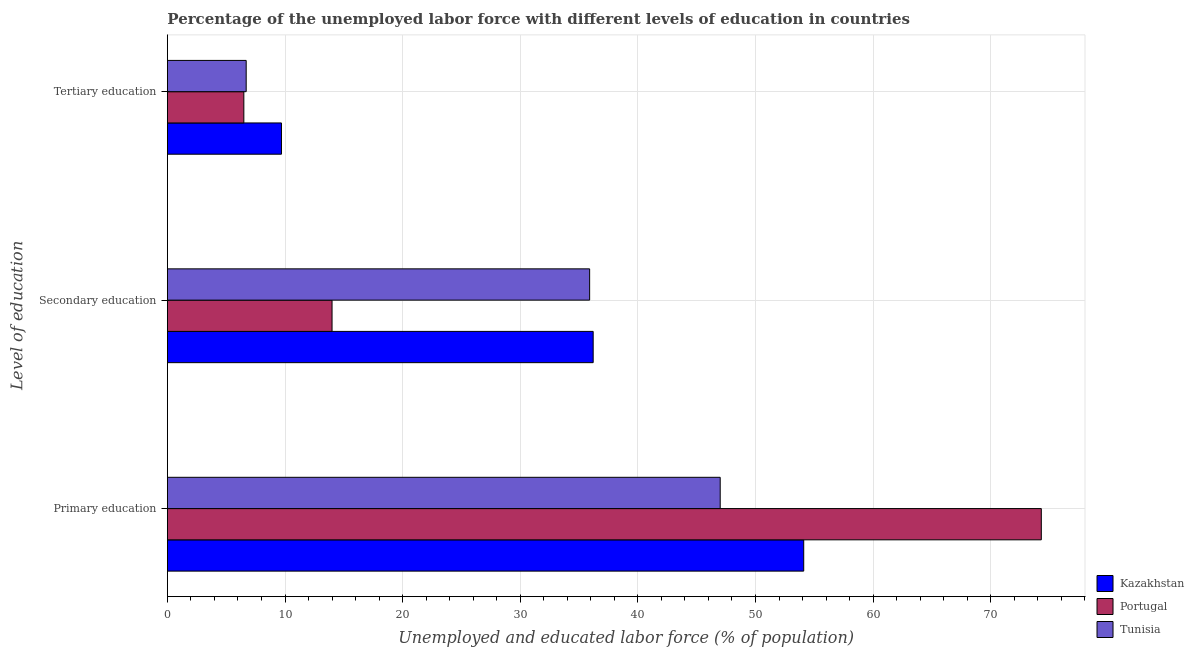How many groups of bars are there?
Provide a short and direct response. 3. Are the number of bars on each tick of the Y-axis equal?
Offer a very short reply. Yes. How many bars are there on the 1st tick from the top?
Offer a terse response. 3. How many bars are there on the 3rd tick from the bottom?
Your answer should be very brief. 3. What is the label of the 1st group of bars from the top?
Offer a terse response. Tertiary education. What is the percentage of labor force who received tertiary education in Tunisia?
Provide a short and direct response. 6.7. Across all countries, what is the maximum percentage of labor force who received primary education?
Make the answer very short. 74.3. In which country was the percentage of labor force who received primary education maximum?
Provide a succinct answer. Portugal. In which country was the percentage of labor force who received primary education minimum?
Your response must be concise. Tunisia. What is the total percentage of labor force who received secondary education in the graph?
Offer a terse response. 86.1. What is the difference between the percentage of labor force who received tertiary education in Kazakhstan and that in Portugal?
Offer a very short reply. 3.2. What is the difference between the percentage of labor force who received secondary education in Kazakhstan and the percentage of labor force who received primary education in Portugal?
Offer a very short reply. -38.1. What is the average percentage of labor force who received tertiary education per country?
Your answer should be compact. 7.63. What is the difference between the percentage of labor force who received secondary education and percentage of labor force who received primary education in Kazakhstan?
Your answer should be very brief. -17.9. What is the ratio of the percentage of labor force who received primary education in Tunisia to that in Portugal?
Keep it short and to the point. 0.63. Is the percentage of labor force who received secondary education in Portugal less than that in Kazakhstan?
Provide a short and direct response. Yes. Is the difference between the percentage of labor force who received primary education in Portugal and Kazakhstan greater than the difference between the percentage of labor force who received tertiary education in Portugal and Kazakhstan?
Give a very brief answer. Yes. What is the difference between the highest and the second highest percentage of labor force who received primary education?
Make the answer very short. 20.2. What is the difference between the highest and the lowest percentage of labor force who received tertiary education?
Provide a short and direct response. 3.2. Is the sum of the percentage of labor force who received secondary education in Tunisia and Portugal greater than the maximum percentage of labor force who received primary education across all countries?
Make the answer very short. No. What does the 1st bar from the top in Primary education represents?
Your response must be concise. Tunisia. Is it the case that in every country, the sum of the percentage of labor force who received primary education and percentage of labor force who received secondary education is greater than the percentage of labor force who received tertiary education?
Give a very brief answer. Yes. Are all the bars in the graph horizontal?
Provide a succinct answer. Yes. What is the difference between two consecutive major ticks on the X-axis?
Keep it short and to the point. 10. Are the values on the major ticks of X-axis written in scientific E-notation?
Make the answer very short. No. Does the graph contain grids?
Your answer should be very brief. Yes. Where does the legend appear in the graph?
Make the answer very short. Bottom right. How many legend labels are there?
Your answer should be very brief. 3. How are the legend labels stacked?
Your answer should be compact. Vertical. What is the title of the graph?
Provide a short and direct response. Percentage of the unemployed labor force with different levels of education in countries. Does "Mongolia" appear as one of the legend labels in the graph?
Your answer should be compact. No. What is the label or title of the X-axis?
Your response must be concise. Unemployed and educated labor force (% of population). What is the label or title of the Y-axis?
Your answer should be compact. Level of education. What is the Unemployed and educated labor force (% of population) in Kazakhstan in Primary education?
Your answer should be very brief. 54.1. What is the Unemployed and educated labor force (% of population) of Portugal in Primary education?
Your answer should be compact. 74.3. What is the Unemployed and educated labor force (% of population) of Tunisia in Primary education?
Offer a terse response. 47. What is the Unemployed and educated labor force (% of population) of Kazakhstan in Secondary education?
Provide a succinct answer. 36.2. What is the Unemployed and educated labor force (% of population) of Portugal in Secondary education?
Your answer should be compact. 14. What is the Unemployed and educated labor force (% of population) of Tunisia in Secondary education?
Offer a terse response. 35.9. What is the Unemployed and educated labor force (% of population) in Kazakhstan in Tertiary education?
Offer a terse response. 9.7. What is the Unemployed and educated labor force (% of population) of Tunisia in Tertiary education?
Your response must be concise. 6.7. Across all Level of education, what is the maximum Unemployed and educated labor force (% of population) in Kazakhstan?
Your response must be concise. 54.1. Across all Level of education, what is the maximum Unemployed and educated labor force (% of population) of Portugal?
Your response must be concise. 74.3. Across all Level of education, what is the maximum Unemployed and educated labor force (% of population) of Tunisia?
Provide a succinct answer. 47. Across all Level of education, what is the minimum Unemployed and educated labor force (% of population) of Kazakhstan?
Ensure brevity in your answer.  9.7. Across all Level of education, what is the minimum Unemployed and educated labor force (% of population) in Portugal?
Provide a succinct answer. 6.5. Across all Level of education, what is the minimum Unemployed and educated labor force (% of population) of Tunisia?
Offer a terse response. 6.7. What is the total Unemployed and educated labor force (% of population) in Kazakhstan in the graph?
Ensure brevity in your answer.  100. What is the total Unemployed and educated labor force (% of population) of Portugal in the graph?
Your answer should be very brief. 94.8. What is the total Unemployed and educated labor force (% of population) of Tunisia in the graph?
Offer a terse response. 89.6. What is the difference between the Unemployed and educated labor force (% of population) in Portugal in Primary education and that in Secondary education?
Ensure brevity in your answer.  60.3. What is the difference between the Unemployed and educated labor force (% of population) in Tunisia in Primary education and that in Secondary education?
Provide a succinct answer. 11.1. What is the difference between the Unemployed and educated labor force (% of population) in Kazakhstan in Primary education and that in Tertiary education?
Your response must be concise. 44.4. What is the difference between the Unemployed and educated labor force (% of population) of Portugal in Primary education and that in Tertiary education?
Offer a terse response. 67.8. What is the difference between the Unemployed and educated labor force (% of population) in Tunisia in Primary education and that in Tertiary education?
Give a very brief answer. 40.3. What is the difference between the Unemployed and educated labor force (% of population) of Kazakhstan in Secondary education and that in Tertiary education?
Offer a terse response. 26.5. What is the difference between the Unemployed and educated labor force (% of population) in Tunisia in Secondary education and that in Tertiary education?
Your answer should be very brief. 29.2. What is the difference between the Unemployed and educated labor force (% of population) in Kazakhstan in Primary education and the Unemployed and educated labor force (% of population) in Portugal in Secondary education?
Your answer should be compact. 40.1. What is the difference between the Unemployed and educated labor force (% of population) in Kazakhstan in Primary education and the Unemployed and educated labor force (% of population) in Tunisia in Secondary education?
Offer a terse response. 18.2. What is the difference between the Unemployed and educated labor force (% of population) in Portugal in Primary education and the Unemployed and educated labor force (% of population) in Tunisia in Secondary education?
Your answer should be very brief. 38.4. What is the difference between the Unemployed and educated labor force (% of population) of Kazakhstan in Primary education and the Unemployed and educated labor force (% of population) of Portugal in Tertiary education?
Your answer should be very brief. 47.6. What is the difference between the Unemployed and educated labor force (% of population) in Kazakhstan in Primary education and the Unemployed and educated labor force (% of population) in Tunisia in Tertiary education?
Ensure brevity in your answer.  47.4. What is the difference between the Unemployed and educated labor force (% of population) in Portugal in Primary education and the Unemployed and educated labor force (% of population) in Tunisia in Tertiary education?
Provide a succinct answer. 67.6. What is the difference between the Unemployed and educated labor force (% of population) in Kazakhstan in Secondary education and the Unemployed and educated labor force (% of population) in Portugal in Tertiary education?
Ensure brevity in your answer.  29.7. What is the difference between the Unemployed and educated labor force (% of population) of Kazakhstan in Secondary education and the Unemployed and educated labor force (% of population) of Tunisia in Tertiary education?
Offer a terse response. 29.5. What is the average Unemployed and educated labor force (% of population) in Kazakhstan per Level of education?
Your response must be concise. 33.33. What is the average Unemployed and educated labor force (% of population) of Portugal per Level of education?
Your answer should be compact. 31.6. What is the average Unemployed and educated labor force (% of population) in Tunisia per Level of education?
Keep it short and to the point. 29.87. What is the difference between the Unemployed and educated labor force (% of population) in Kazakhstan and Unemployed and educated labor force (% of population) in Portugal in Primary education?
Your answer should be compact. -20.2. What is the difference between the Unemployed and educated labor force (% of population) of Portugal and Unemployed and educated labor force (% of population) of Tunisia in Primary education?
Make the answer very short. 27.3. What is the difference between the Unemployed and educated labor force (% of population) of Kazakhstan and Unemployed and educated labor force (% of population) of Portugal in Secondary education?
Keep it short and to the point. 22.2. What is the difference between the Unemployed and educated labor force (% of population) in Portugal and Unemployed and educated labor force (% of population) in Tunisia in Secondary education?
Your response must be concise. -21.9. What is the difference between the Unemployed and educated labor force (% of population) in Kazakhstan and Unemployed and educated labor force (% of population) in Portugal in Tertiary education?
Provide a succinct answer. 3.2. What is the ratio of the Unemployed and educated labor force (% of population) of Kazakhstan in Primary education to that in Secondary education?
Keep it short and to the point. 1.49. What is the ratio of the Unemployed and educated labor force (% of population) of Portugal in Primary education to that in Secondary education?
Make the answer very short. 5.31. What is the ratio of the Unemployed and educated labor force (% of population) of Tunisia in Primary education to that in Secondary education?
Your answer should be very brief. 1.31. What is the ratio of the Unemployed and educated labor force (% of population) in Kazakhstan in Primary education to that in Tertiary education?
Your response must be concise. 5.58. What is the ratio of the Unemployed and educated labor force (% of population) in Portugal in Primary education to that in Tertiary education?
Your answer should be compact. 11.43. What is the ratio of the Unemployed and educated labor force (% of population) in Tunisia in Primary education to that in Tertiary education?
Provide a succinct answer. 7.01. What is the ratio of the Unemployed and educated labor force (% of population) in Kazakhstan in Secondary education to that in Tertiary education?
Ensure brevity in your answer.  3.73. What is the ratio of the Unemployed and educated labor force (% of population) of Portugal in Secondary education to that in Tertiary education?
Your response must be concise. 2.15. What is the ratio of the Unemployed and educated labor force (% of population) in Tunisia in Secondary education to that in Tertiary education?
Your response must be concise. 5.36. What is the difference between the highest and the second highest Unemployed and educated labor force (% of population) in Kazakhstan?
Give a very brief answer. 17.9. What is the difference between the highest and the second highest Unemployed and educated labor force (% of population) in Portugal?
Your answer should be very brief. 60.3. What is the difference between the highest and the lowest Unemployed and educated labor force (% of population) in Kazakhstan?
Provide a succinct answer. 44.4. What is the difference between the highest and the lowest Unemployed and educated labor force (% of population) in Portugal?
Provide a succinct answer. 67.8. What is the difference between the highest and the lowest Unemployed and educated labor force (% of population) of Tunisia?
Make the answer very short. 40.3. 